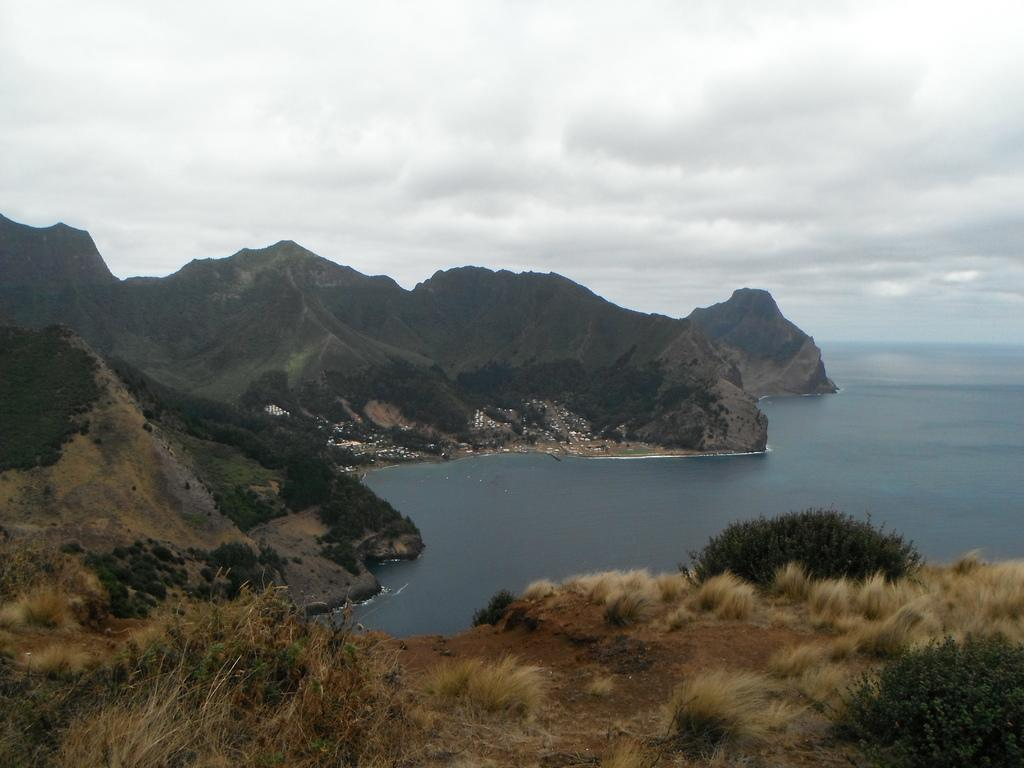What type of natural landscape can be seen in the image? There are mountains, dried grass, bushes, and a sea visible in the image. Can you describe the vegetation in the image? There is dried grass and bushes visible in the image. What is the condition of the sea in the image? Water is flowing in the sea in the image. How many kittens are playing with the lead in the image? There are no kittens or lead present in the image. What type of sheep can be seen grazing on the dried grass in the image? There are no sheep present in the image. 